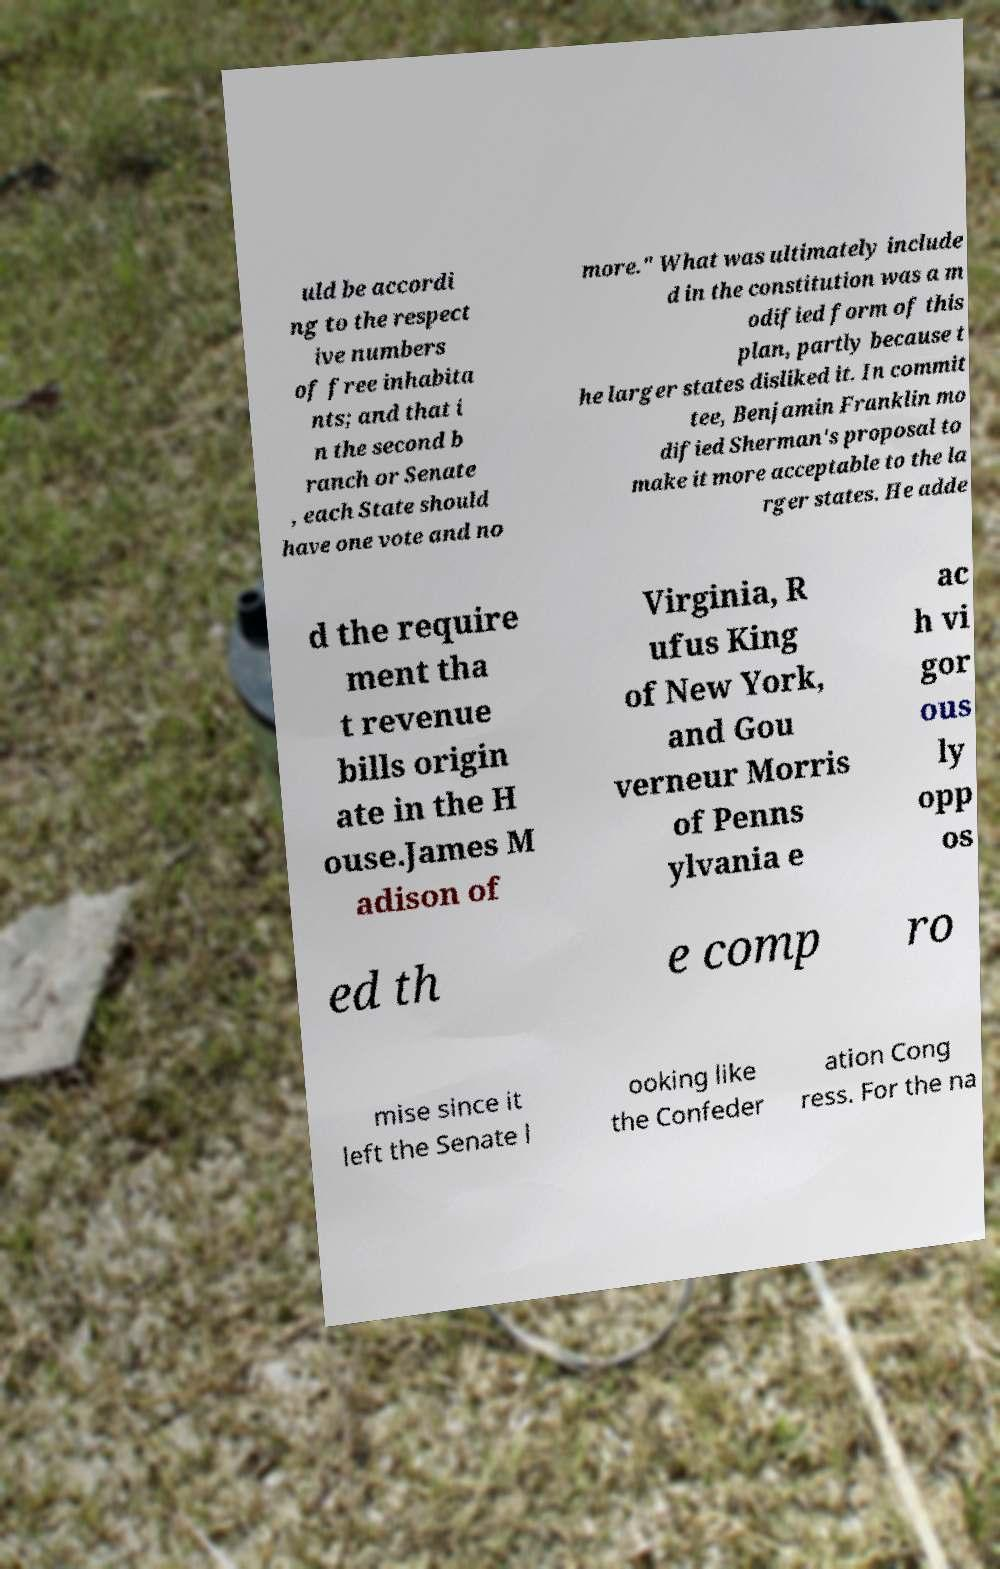I need the written content from this picture converted into text. Can you do that? uld be accordi ng to the respect ive numbers of free inhabita nts; and that i n the second b ranch or Senate , each State should have one vote and no more." What was ultimately include d in the constitution was a m odified form of this plan, partly because t he larger states disliked it. In commit tee, Benjamin Franklin mo dified Sherman's proposal to make it more acceptable to the la rger states. He adde d the require ment tha t revenue bills origin ate in the H ouse.James M adison of Virginia, R ufus King of New York, and Gou verneur Morris of Penns ylvania e ac h vi gor ous ly opp os ed th e comp ro mise since it left the Senate l ooking like the Confeder ation Cong ress. For the na 